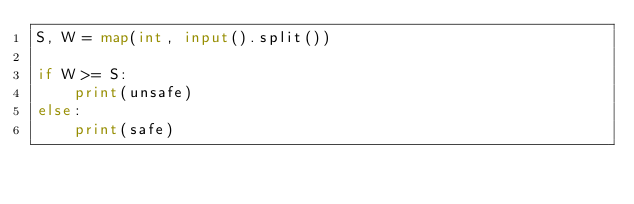Convert code to text. <code><loc_0><loc_0><loc_500><loc_500><_Python_>S, W = map(int, input().split())

if W >= S:
    print(unsafe)
else:
    print(safe)
</code> 